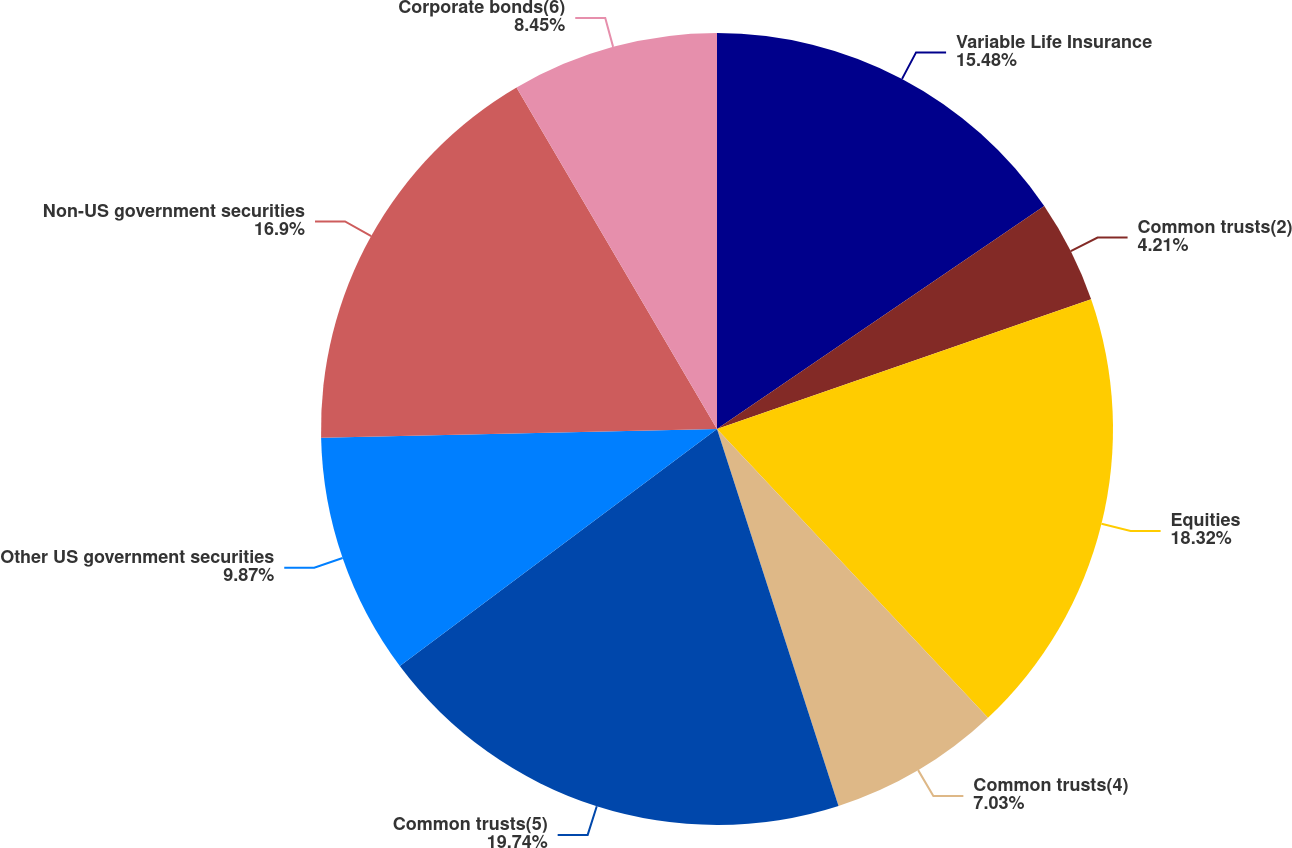Convert chart to OTSL. <chart><loc_0><loc_0><loc_500><loc_500><pie_chart><fcel>Variable Life Insurance<fcel>Common trusts(2)<fcel>Equities<fcel>Common trusts(4)<fcel>Common trusts(5)<fcel>Other US government securities<fcel>Non-US government securities<fcel>Corporate bonds(6)<nl><fcel>15.48%<fcel>4.21%<fcel>18.32%<fcel>7.03%<fcel>19.75%<fcel>9.87%<fcel>16.9%<fcel>8.45%<nl></chart> 